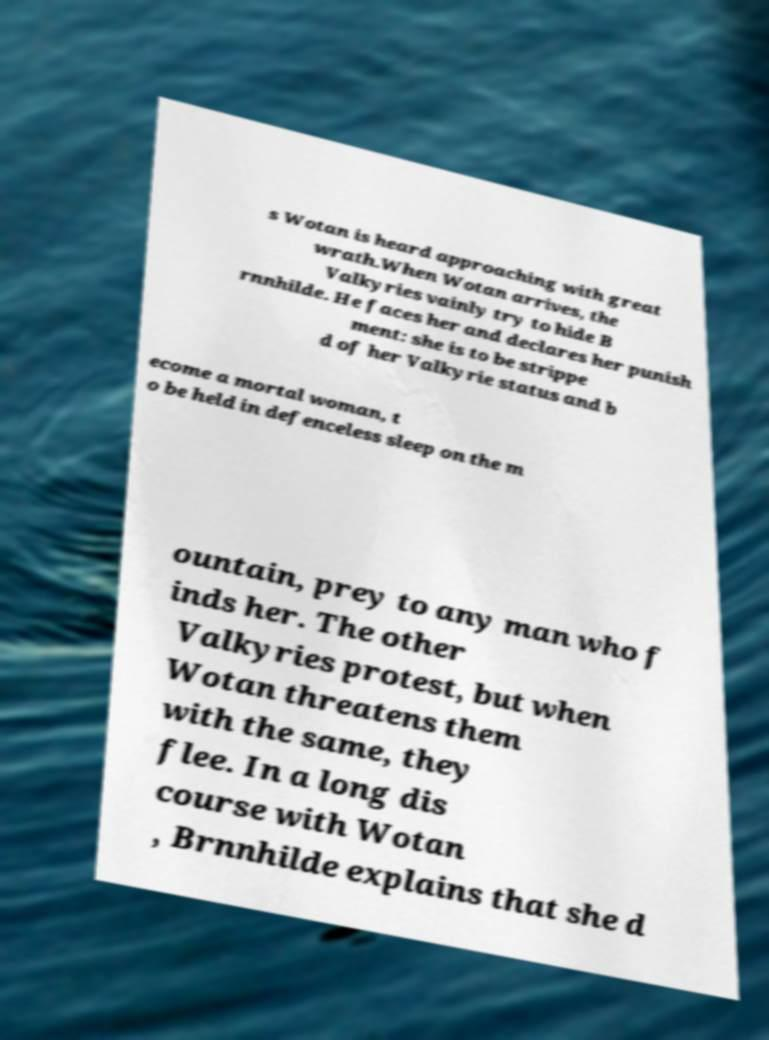Can you read and provide the text displayed in the image?This photo seems to have some interesting text. Can you extract and type it out for me? s Wotan is heard approaching with great wrath.When Wotan arrives, the Valkyries vainly try to hide B rnnhilde. He faces her and declares her punish ment: she is to be strippe d of her Valkyrie status and b ecome a mortal woman, t o be held in defenceless sleep on the m ountain, prey to any man who f inds her. The other Valkyries protest, but when Wotan threatens them with the same, they flee. In a long dis course with Wotan , Brnnhilde explains that she d 